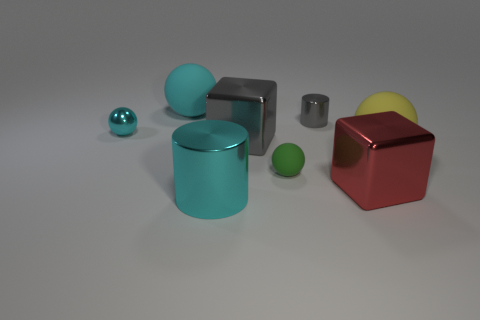Subtract all matte spheres. How many spheres are left? 1 Subtract all purple balls. Subtract all purple blocks. How many balls are left? 4 Add 2 large yellow rubber balls. How many objects exist? 10 Subtract all blocks. How many objects are left? 6 Subtract 1 red blocks. How many objects are left? 7 Subtract all gray things. Subtract all tiny blue matte objects. How many objects are left? 6 Add 1 spheres. How many spheres are left? 5 Add 2 tiny red cylinders. How many tiny red cylinders exist? 2 